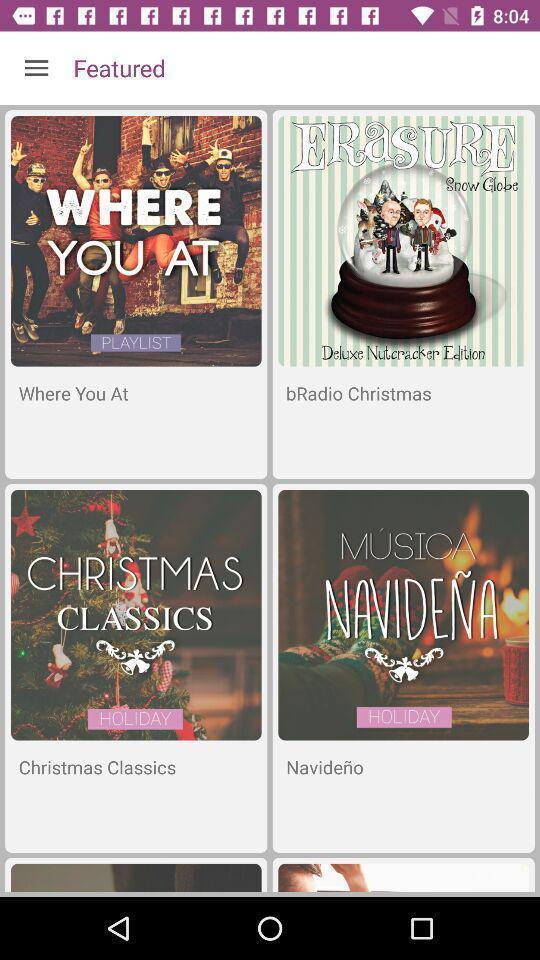Summarize the main components in this picture. Various kinds of events to select in application. 